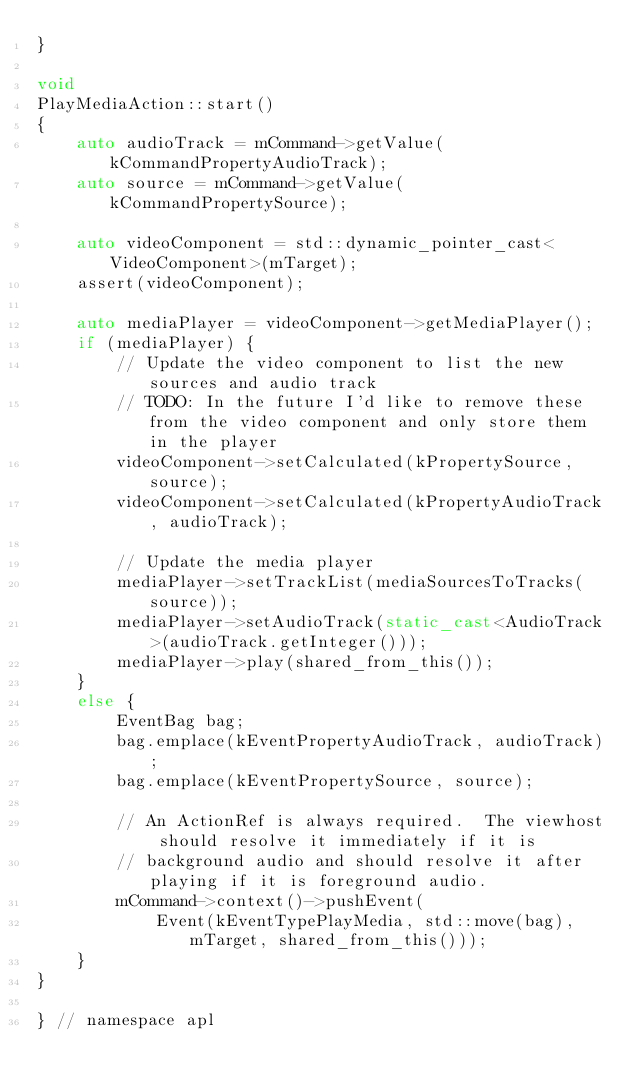Convert code to text. <code><loc_0><loc_0><loc_500><loc_500><_C++_>}

void
PlayMediaAction::start()
{
    auto audioTrack = mCommand->getValue(kCommandPropertyAudioTrack);
    auto source = mCommand->getValue(kCommandPropertySource);

    auto videoComponent = std::dynamic_pointer_cast<VideoComponent>(mTarget);
    assert(videoComponent);

    auto mediaPlayer = videoComponent->getMediaPlayer();
    if (mediaPlayer) {
        // Update the video component to list the new sources and audio track
        // TODO: In the future I'd like to remove these from the video component and only store them in the player
        videoComponent->setCalculated(kPropertySource, source);
        videoComponent->setCalculated(kPropertyAudioTrack, audioTrack);

        // Update the media player
        mediaPlayer->setTrackList(mediaSourcesToTracks(source));
        mediaPlayer->setAudioTrack(static_cast<AudioTrack>(audioTrack.getInteger()));
        mediaPlayer->play(shared_from_this());
    }
    else {
        EventBag bag;
        bag.emplace(kEventPropertyAudioTrack, audioTrack);
        bag.emplace(kEventPropertySource, source);

        // An ActionRef is always required.  The viewhost should resolve it immediately if it is
        // background audio and should resolve it after playing if it is foreground audio.
        mCommand->context()->pushEvent(
            Event(kEventTypePlayMedia, std::move(bag), mTarget, shared_from_this()));
    }
}

} // namespace apl</code> 